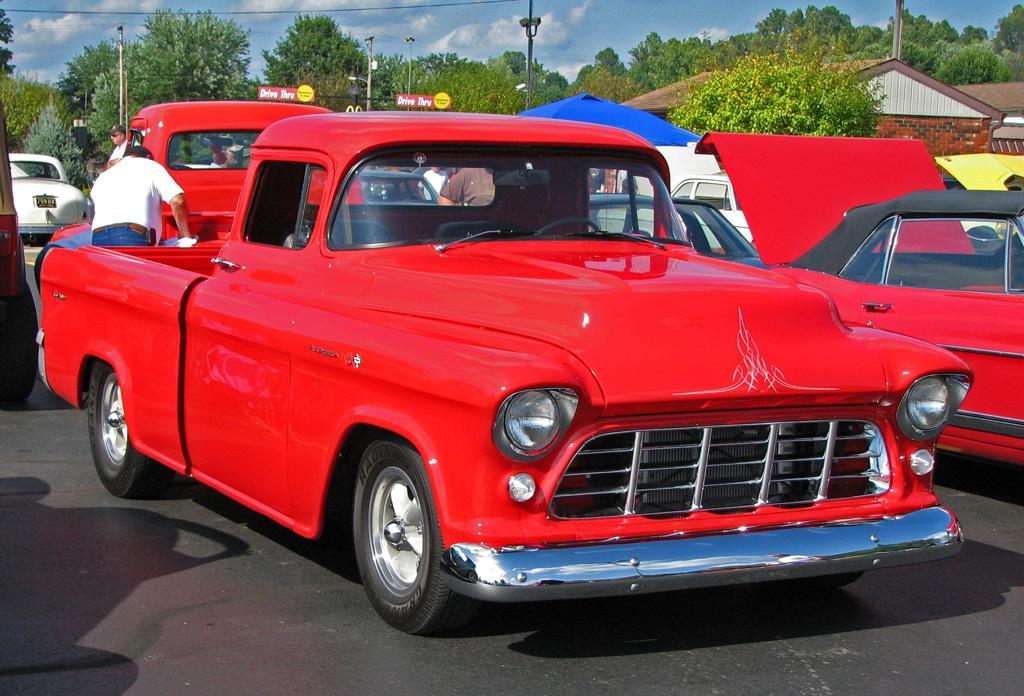What can be seen on the road in the image? There are cars and persons on the road in the image. What is visible in the background of the image? There are buildings, trees, poles, and the sky visible in the background of the image. What is the condition of the sky in the image? The sky is visible in the background of the image, and clouds are present. How does the image show an increase in debt? The image does not show an increase in debt; it depicts cars, persons, buildings, trees, poles, and the sky. What type of wheel is present in the image? There is no wheel present in the image; it features cars, persons, buildings, trees, poles, and the sky. 